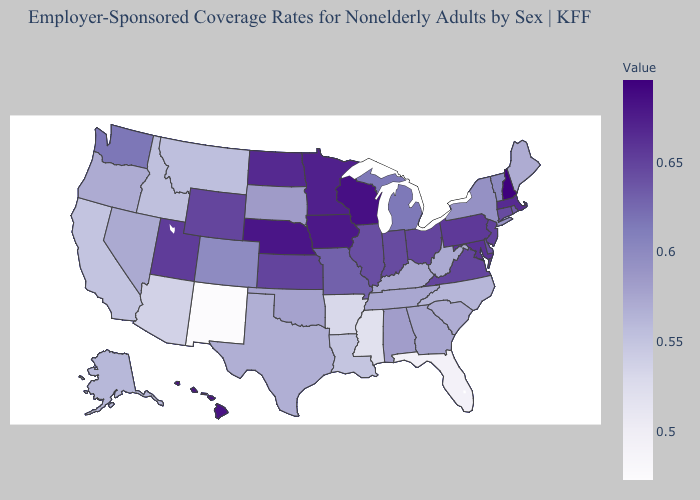Does Alabama have the lowest value in the South?
Quick response, please. No. Does New York have a lower value than Maryland?
Quick response, please. Yes. Which states have the lowest value in the Northeast?
Write a very short answer. Maine. Does Washington have the lowest value in the West?
Answer briefly. No. Does Massachusetts have the highest value in the Northeast?
Short answer required. No. Does New Mexico have the lowest value in the USA?
Quick response, please. Yes. 